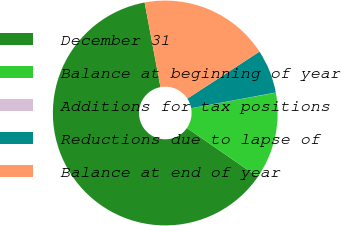Convert chart. <chart><loc_0><loc_0><loc_500><loc_500><pie_chart><fcel>December 31<fcel>Balance at beginning of year<fcel>Additions for tax positions<fcel>Reductions due to lapse of<fcel>Balance at end of year<nl><fcel>62.43%<fcel>12.51%<fcel>0.03%<fcel>6.27%<fcel>18.75%<nl></chart> 